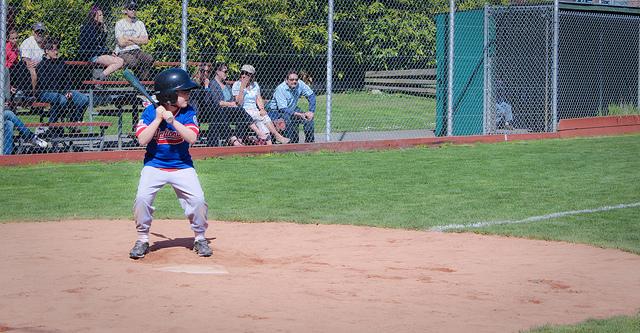What sport is this child playing?
Answer briefly. Baseball. Is this regular baseball?
Keep it brief. No. Where are the spectators?
Quick response, please. Bleachers. What is in the player's hands?
Quick response, please. Bat. 